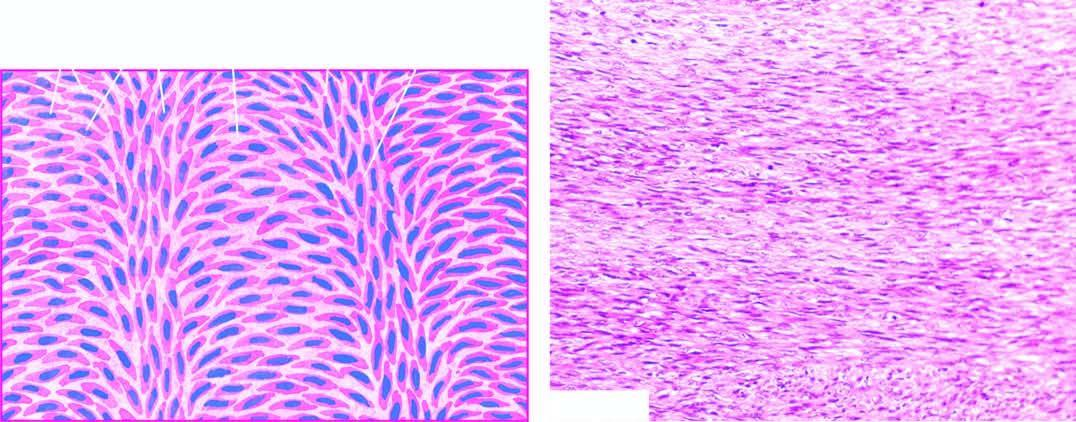does microscopy show a well-differentiated tumour composed of spindle-shaped cells forming interlacing fascicles producing a typical herring-bone pattern?
Answer the question using a single word or phrase. Yes 